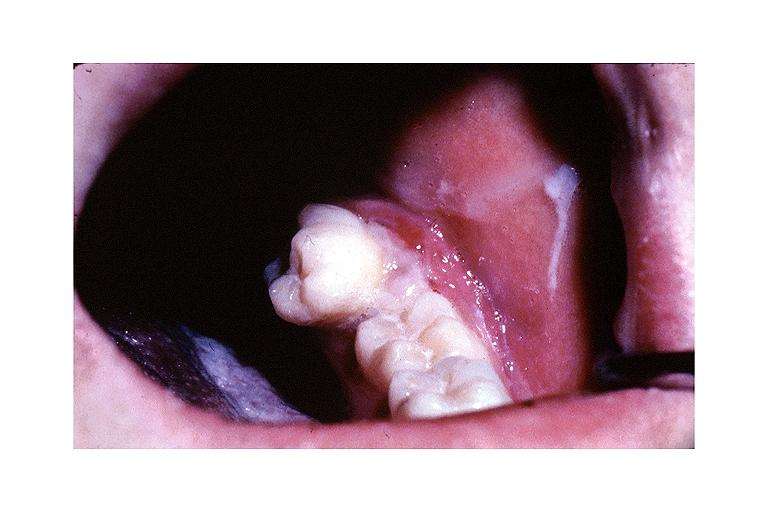does hypertrophic gastritis show metastatic adenocarcinoma?
Answer the question using a single word or phrase. No 